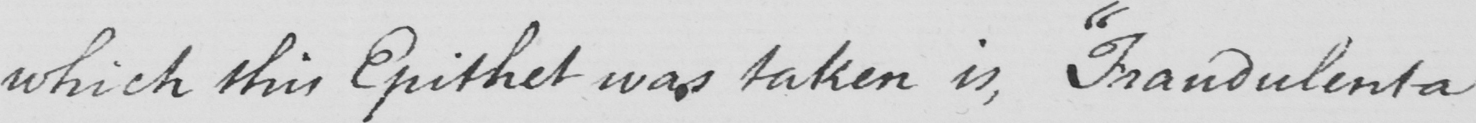Can you read and transcribe this handwriting? which this Epithet was taken is ,  " Fraudulenta 